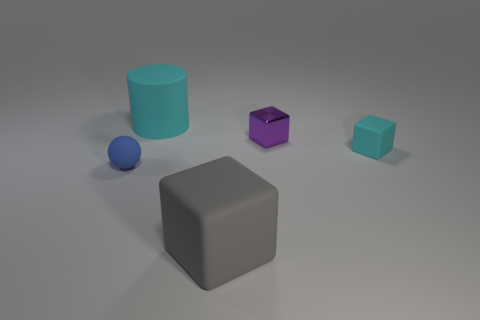How big is the cyan thing that is to the left of the large matte object that is in front of the blue rubber thing?
Give a very brief answer. Large. Is the size of the shiny block the same as the cube that is in front of the blue ball?
Offer a terse response. No. What is the material of the tiny purple object that is the same shape as the large gray rubber thing?
Provide a short and direct response. Metal. What number of small cyan objects have the same shape as the gray matte object?
Your response must be concise. 1. Is the big cylinder made of the same material as the small object that is behind the small rubber block?
Provide a succinct answer. No. Are there more gray matte objects that are in front of the tiny cyan thing than small green metallic cubes?
Offer a terse response. Yes. The matte object that is the same color as the tiny matte cube is what shape?
Give a very brief answer. Cylinder. Is there another purple block that has the same material as the purple block?
Your response must be concise. No. Do the cube in front of the blue matte object and the cyan thing that is to the right of the cylinder have the same material?
Ensure brevity in your answer.  Yes. Are there an equal number of gray blocks on the left side of the big cyan cylinder and gray matte objects in front of the metal thing?
Offer a terse response. No. 